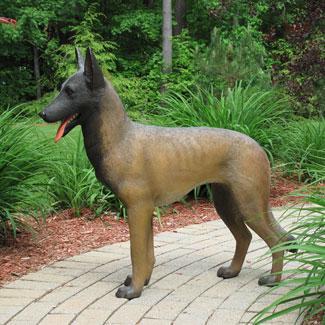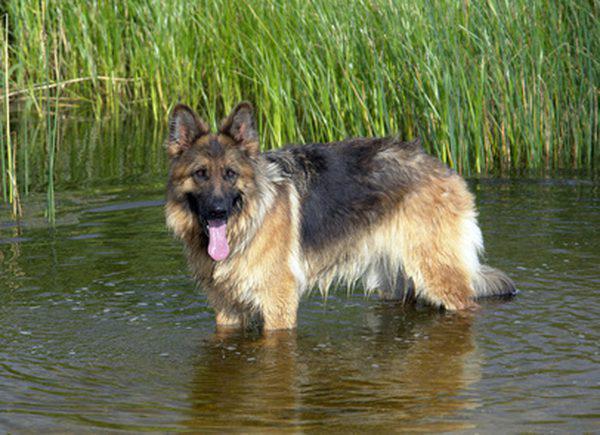The first image is the image on the left, the second image is the image on the right. Assess this claim about the two images: "All dogs have their tongue sticking out.". Correct or not? Answer yes or no. Yes. 